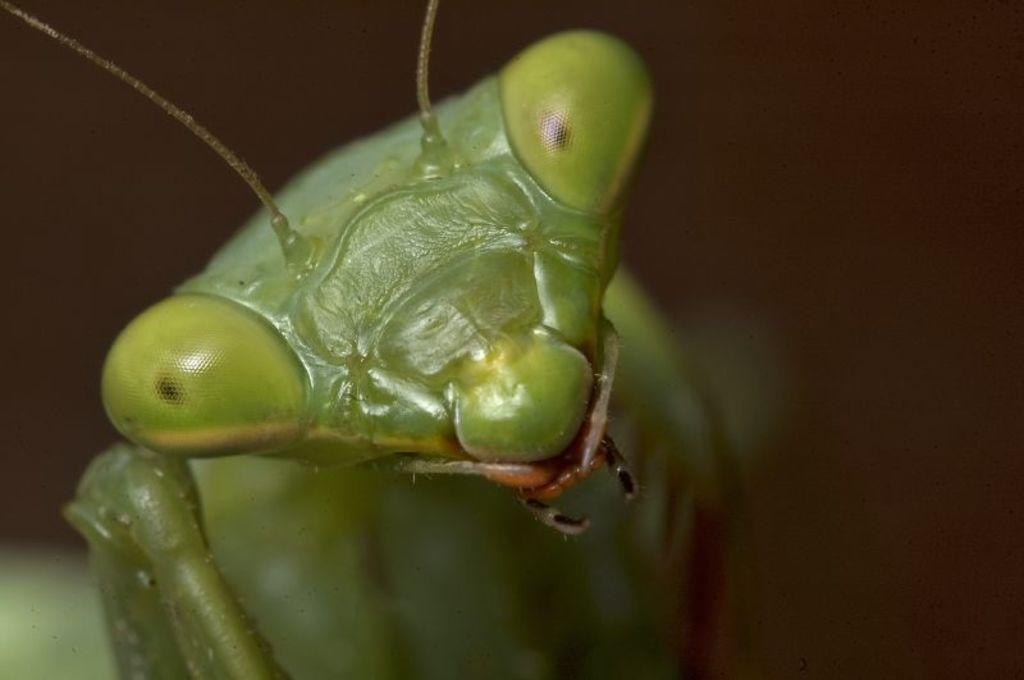What type of living organism can be seen in the image? There is an insect in the image. What is visible in the background of the image? There is a wall in the background of the image. What type of knowledge can be gained from the insect in the image? The image does not provide any specific knowledge about the insect; it simply shows the insect's presence. Is there a doctor present in the image? There is no indication of a doctor or any medical professional in the image. 